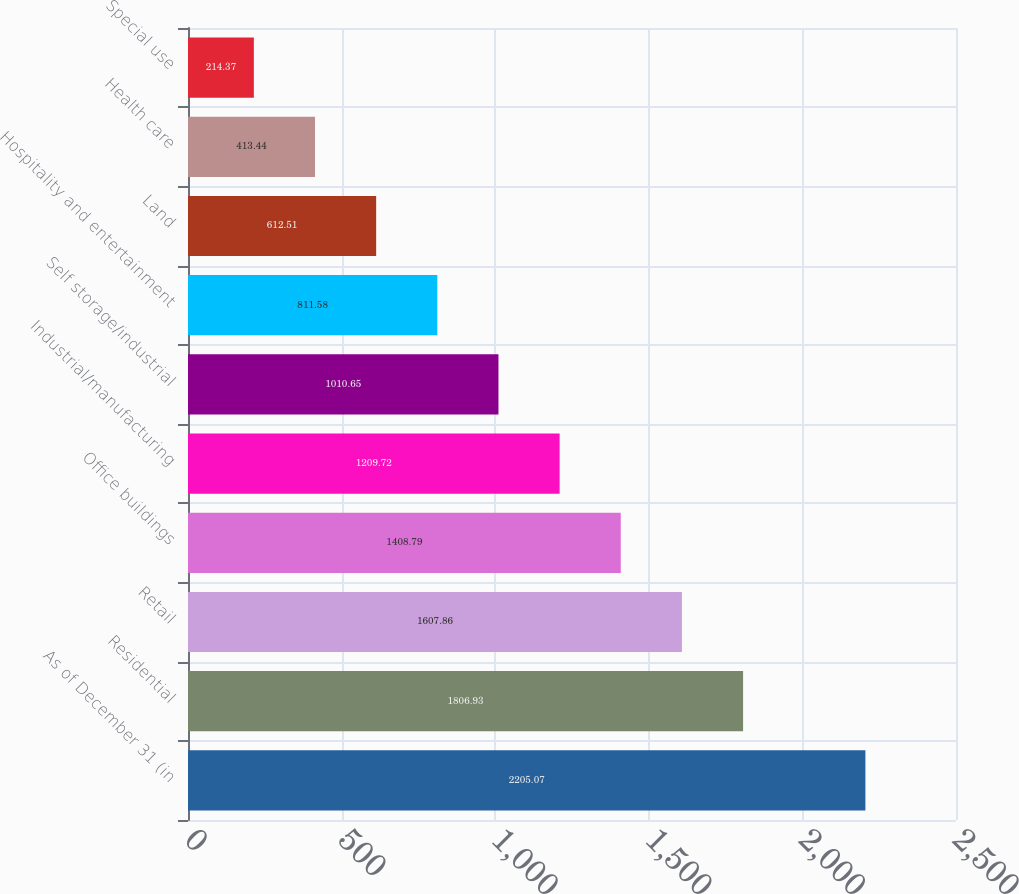Convert chart. <chart><loc_0><loc_0><loc_500><loc_500><bar_chart><fcel>As of December 31 (in<fcel>Residential<fcel>Retail<fcel>Office buildings<fcel>Industrial/manufacturing<fcel>Self storage/industrial<fcel>Hospitality and entertainment<fcel>Land<fcel>Health care<fcel>Special use<nl><fcel>2205.07<fcel>1806.93<fcel>1607.86<fcel>1408.79<fcel>1209.72<fcel>1010.65<fcel>811.58<fcel>612.51<fcel>413.44<fcel>214.37<nl></chart> 